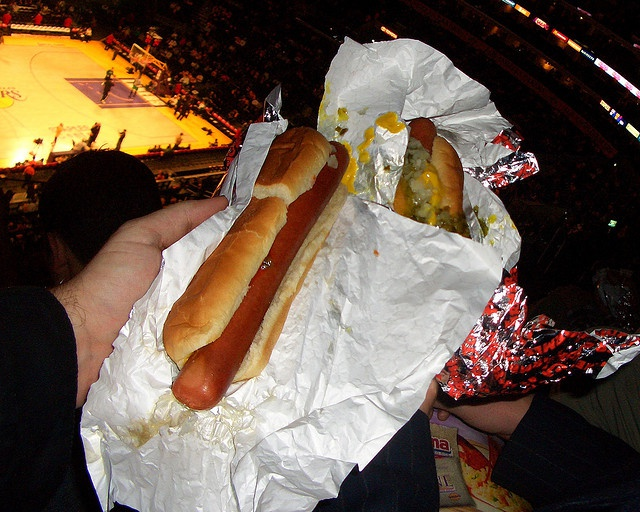Describe the objects in this image and their specific colors. I can see people in maroon, black, gray, tan, and brown tones, people in maroon, black, and brown tones, people in maroon, black, brown, and red tones, hot dog in maroon, brown, and gray tones, and hot dog in maroon, olive, and black tones in this image. 